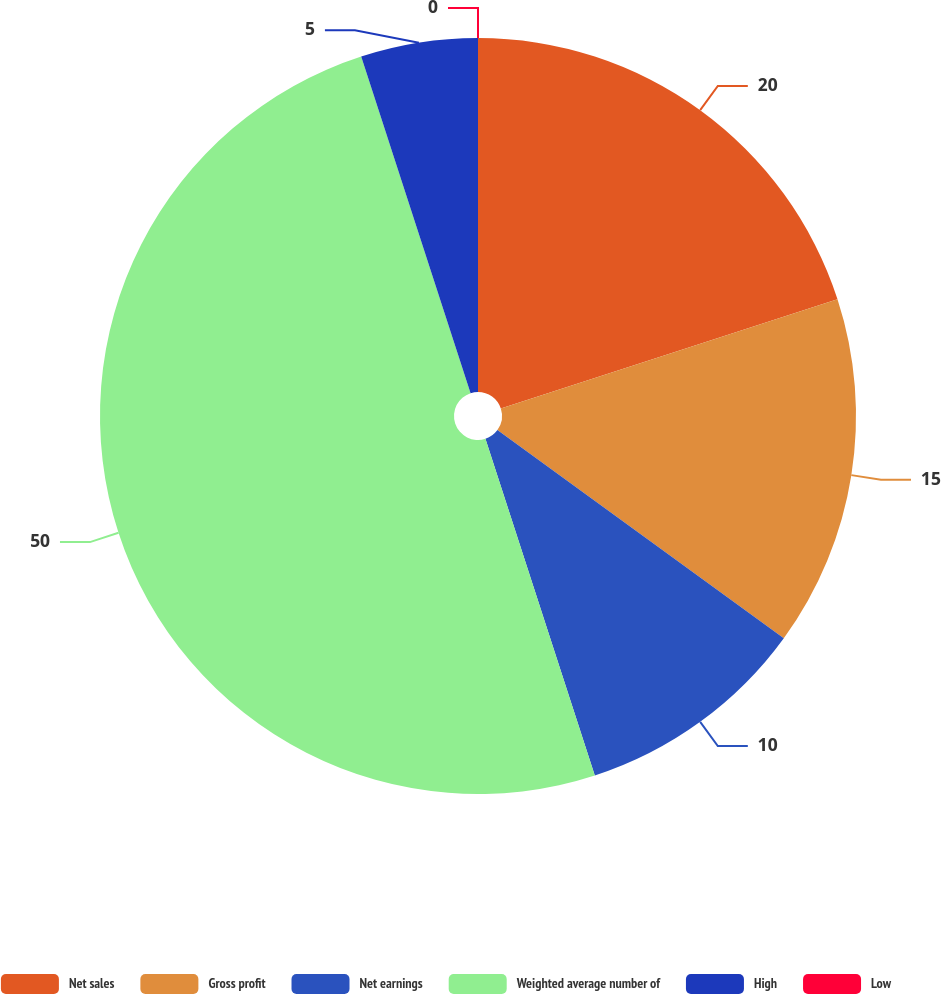Convert chart to OTSL. <chart><loc_0><loc_0><loc_500><loc_500><pie_chart><fcel>Net sales<fcel>Gross profit<fcel>Net earnings<fcel>Weighted average number of<fcel>High<fcel>Low<nl><fcel>20.0%<fcel>15.0%<fcel>10.0%<fcel>50.0%<fcel>5.0%<fcel>0.0%<nl></chart> 